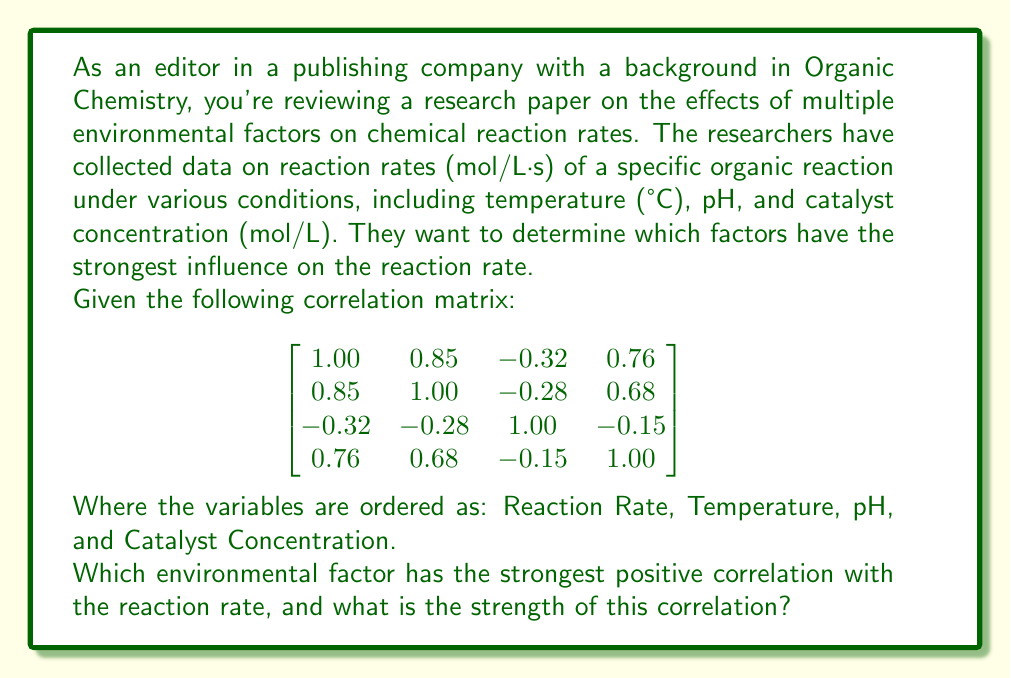Provide a solution to this math problem. To solve this problem, we need to analyze the correlation matrix provided. The correlation matrix shows the pairwise correlations between all variables in the study. The values range from -1 to 1, where:

- 1 indicates a perfect positive correlation
- -1 indicates a perfect negative correlation
- 0 indicates no correlation

The first row (or column) of the matrix represents the correlations between the reaction rate and each of the environmental factors:

1. Correlation between Reaction Rate and Temperature: 0.85
2. Correlation between Reaction Rate and pH: -0.32
3. Correlation between Reaction Rate and Catalyst Concentration: 0.76

To find the strongest positive correlation with the reaction rate, we need to identify the largest positive value among these correlations.

0.85 (Temperature) > 0.76 (Catalyst Concentration) > -0.32 (pH)

Therefore, Temperature has the strongest positive correlation with the reaction rate, with a correlation coefficient of 0.85.

This strong positive correlation suggests that as temperature increases, the reaction rate tends to increase as well. This aligns with the Arrhenius equation and the general principle that higher temperatures typically lead to faster reaction rates in chemical reactions.
Answer: Temperature has the strongest positive correlation with the reaction rate, with a correlation coefficient of 0.85. 